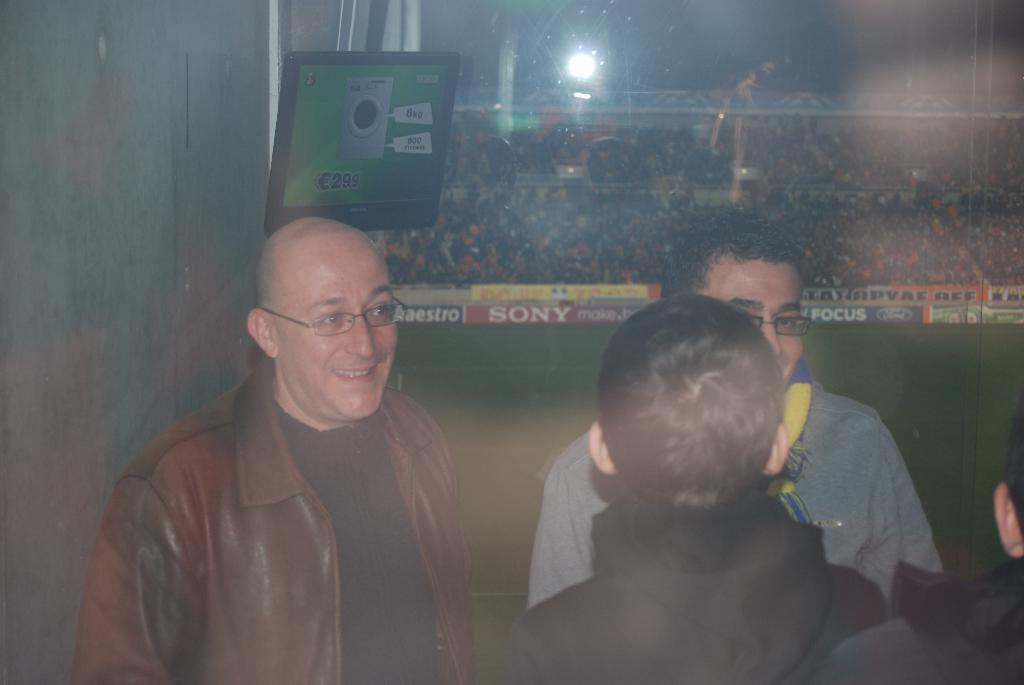Who is present in the image? There are people in the image. What are the people in the image doing? The people are smiling. What electronic device is visible in the image? There is a monitor visible in the image. What can be seen in the background of the image? There are people in a stadium in the background of the image. What songs are the people in the image singing? There is no indication in the image that the people are singing songs, so it cannot be determined from the picture. 